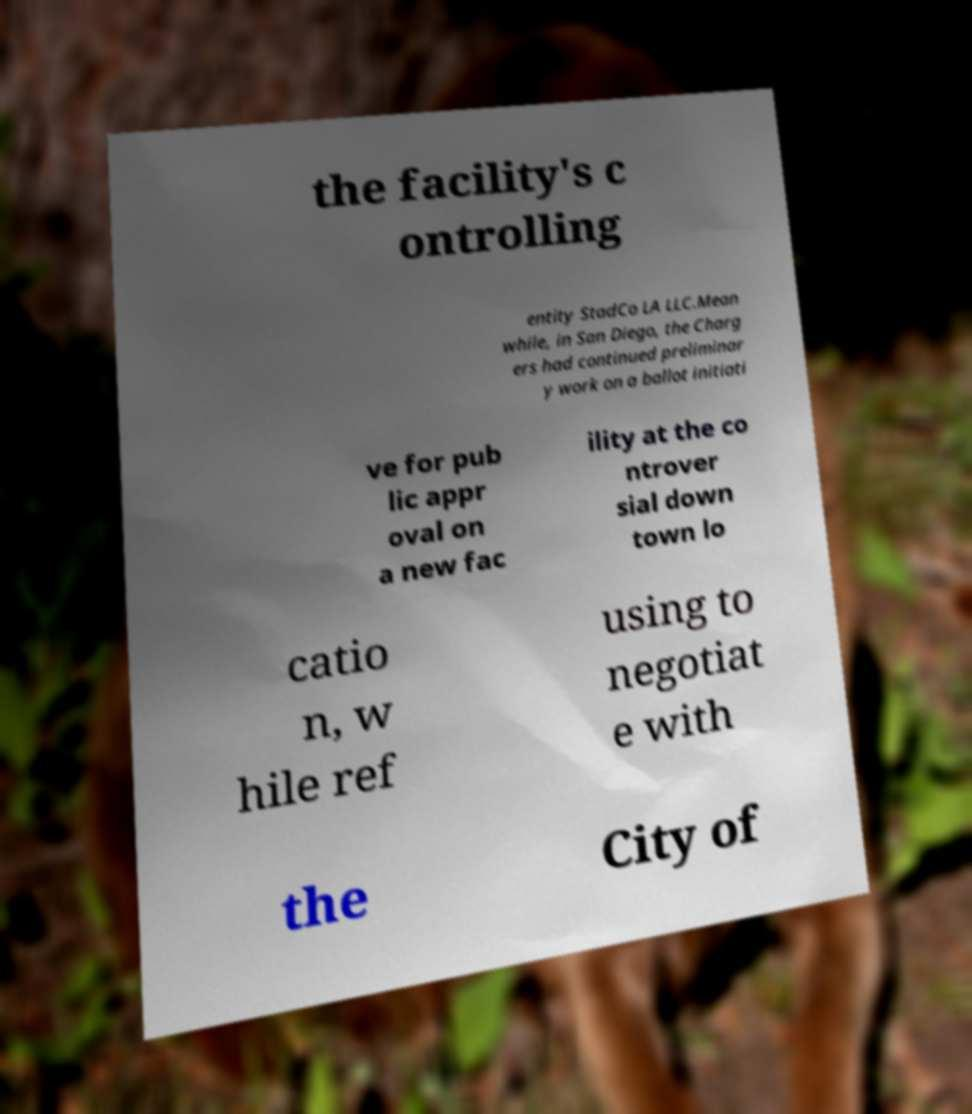Can you read and provide the text displayed in the image?This photo seems to have some interesting text. Can you extract and type it out for me? the facility's c ontrolling entity StadCo LA LLC.Mean while, in San Diego, the Charg ers had continued preliminar y work on a ballot initiati ve for pub lic appr oval on a new fac ility at the co ntrover sial down town lo catio n, w hile ref using to negotiat e with the City of 